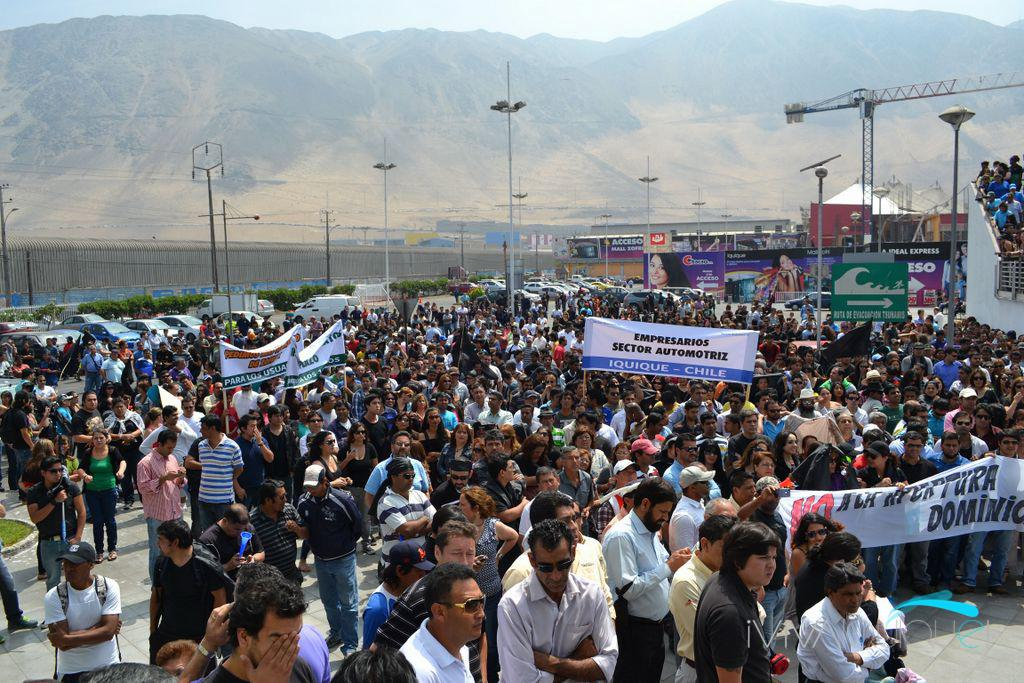What are the people at the bottom of the image doing? The people are standing at the bottom of the image and holding banners. What can be seen attached to the banners to in the image? There are poles visible in the image that have banners attached to them. What else is present in the image besides people and banners? There are vehicles and hills in the background visible in the image. What is visible at the top of the image? The sky is visible at the top of the image. Can you describe the texture of the jelly on the hands of the people in the image? There is no jelly present in the image, and the people's hands are not mentioned. What type of pleasure can be seen being derived from the banners in the image? There is no indication of pleasure in the image; the people are simply holding banners. 